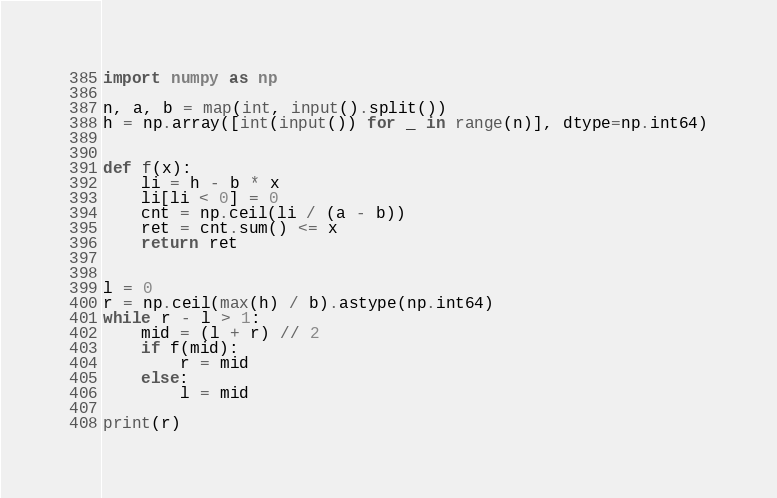<code> <loc_0><loc_0><loc_500><loc_500><_Python_>import numpy as np

n, a, b = map(int, input().split())
h = np.array([int(input()) for _ in range(n)], dtype=np.int64)


def f(x):
    li = h - b * x
    li[li < 0] = 0
    cnt = np.ceil(li / (a - b))
    ret = cnt.sum() <= x
    return ret


l = 0
r = np.ceil(max(h) / b).astype(np.int64)
while r - l > 1:
    mid = (l + r) // 2
    if f(mid):
        r = mid
    else:
        l = mid

print(r)
</code> 